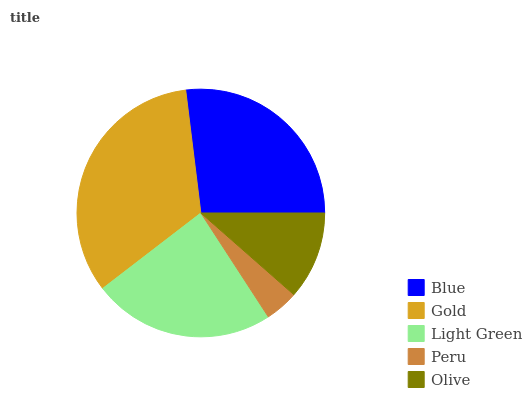Is Peru the minimum?
Answer yes or no. Yes. Is Gold the maximum?
Answer yes or no. Yes. Is Light Green the minimum?
Answer yes or no. No. Is Light Green the maximum?
Answer yes or no. No. Is Gold greater than Light Green?
Answer yes or no. Yes. Is Light Green less than Gold?
Answer yes or no. Yes. Is Light Green greater than Gold?
Answer yes or no. No. Is Gold less than Light Green?
Answer yes or no. No. Is Light Green the high median?
Answer yes or no. Yes. Is Light Green the low median?
Answer yes or no. Yes. Is Gold the high median?
Answer yes or no. No. Is Olive the low median?
Answer yes or no. No. 